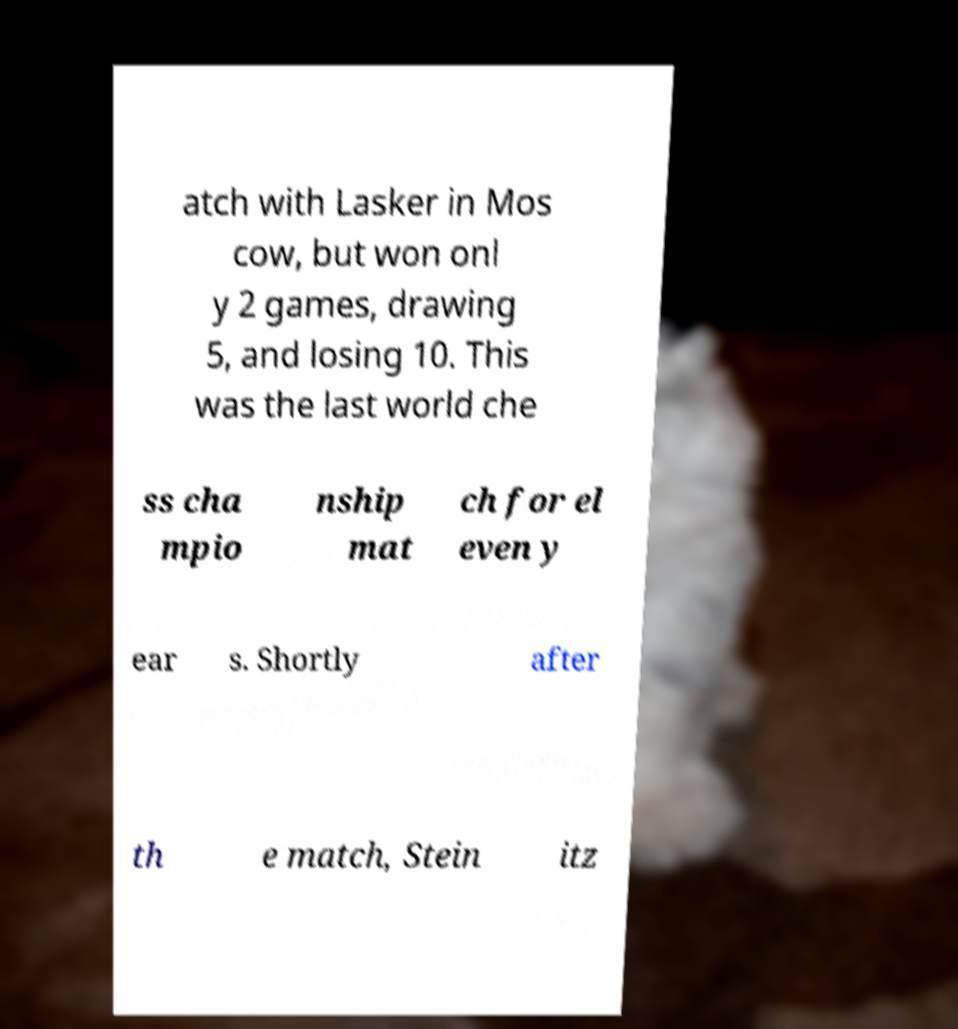Can you read and provide the text displayed in the image?This photo seems to have some interesting text. Can you extract and type it out for me? atch with Lasker in Mos cow, but won onl y 2 games, drawing 5, and losing 10. This was the last world che ss cha mpio nship mat ch for el even y ear s. Shortly after th e match, Stein itz 